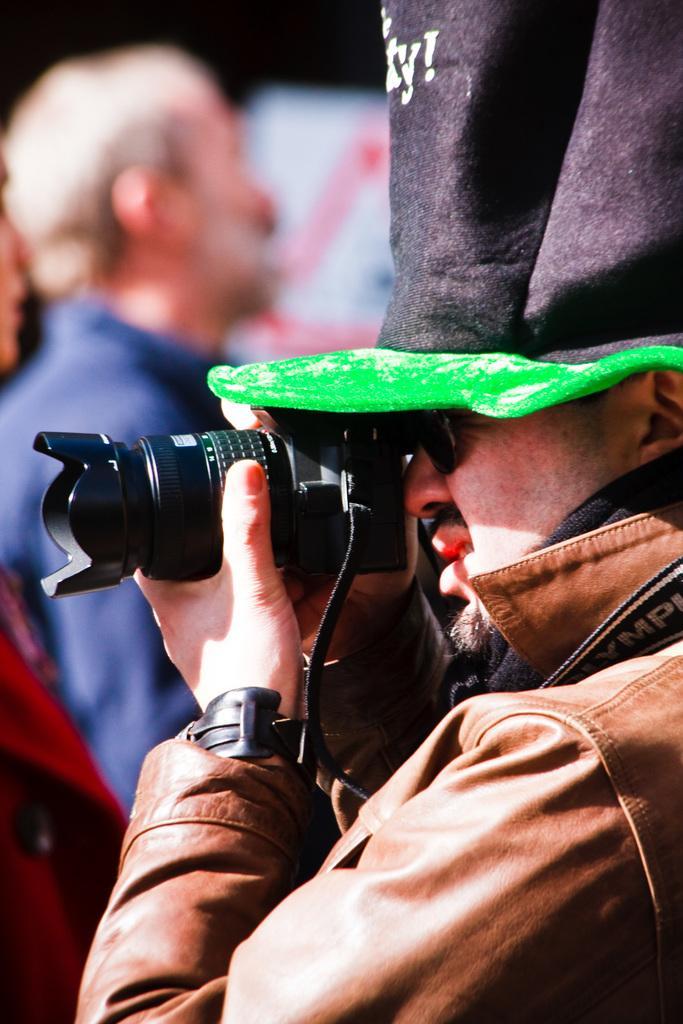In one or two sentences, can you explain what this image depicts? In this picture we can see man wore jacket, cap holding camera in his hand and taking picture and in background we can see other person and it is blurry. 